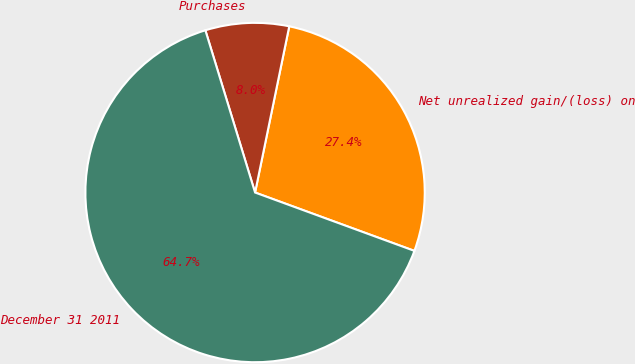Convert chart. <chart><loc_0><loc_0><loc_500><loc_500><pie_chart><fcel>Net unrealized gain/(loss) on<fcel>Purchases<fcel>December 31 2011<nl><fcel>27.36%<fcel>7.96%<fcel>64.68%<nl></chart> 